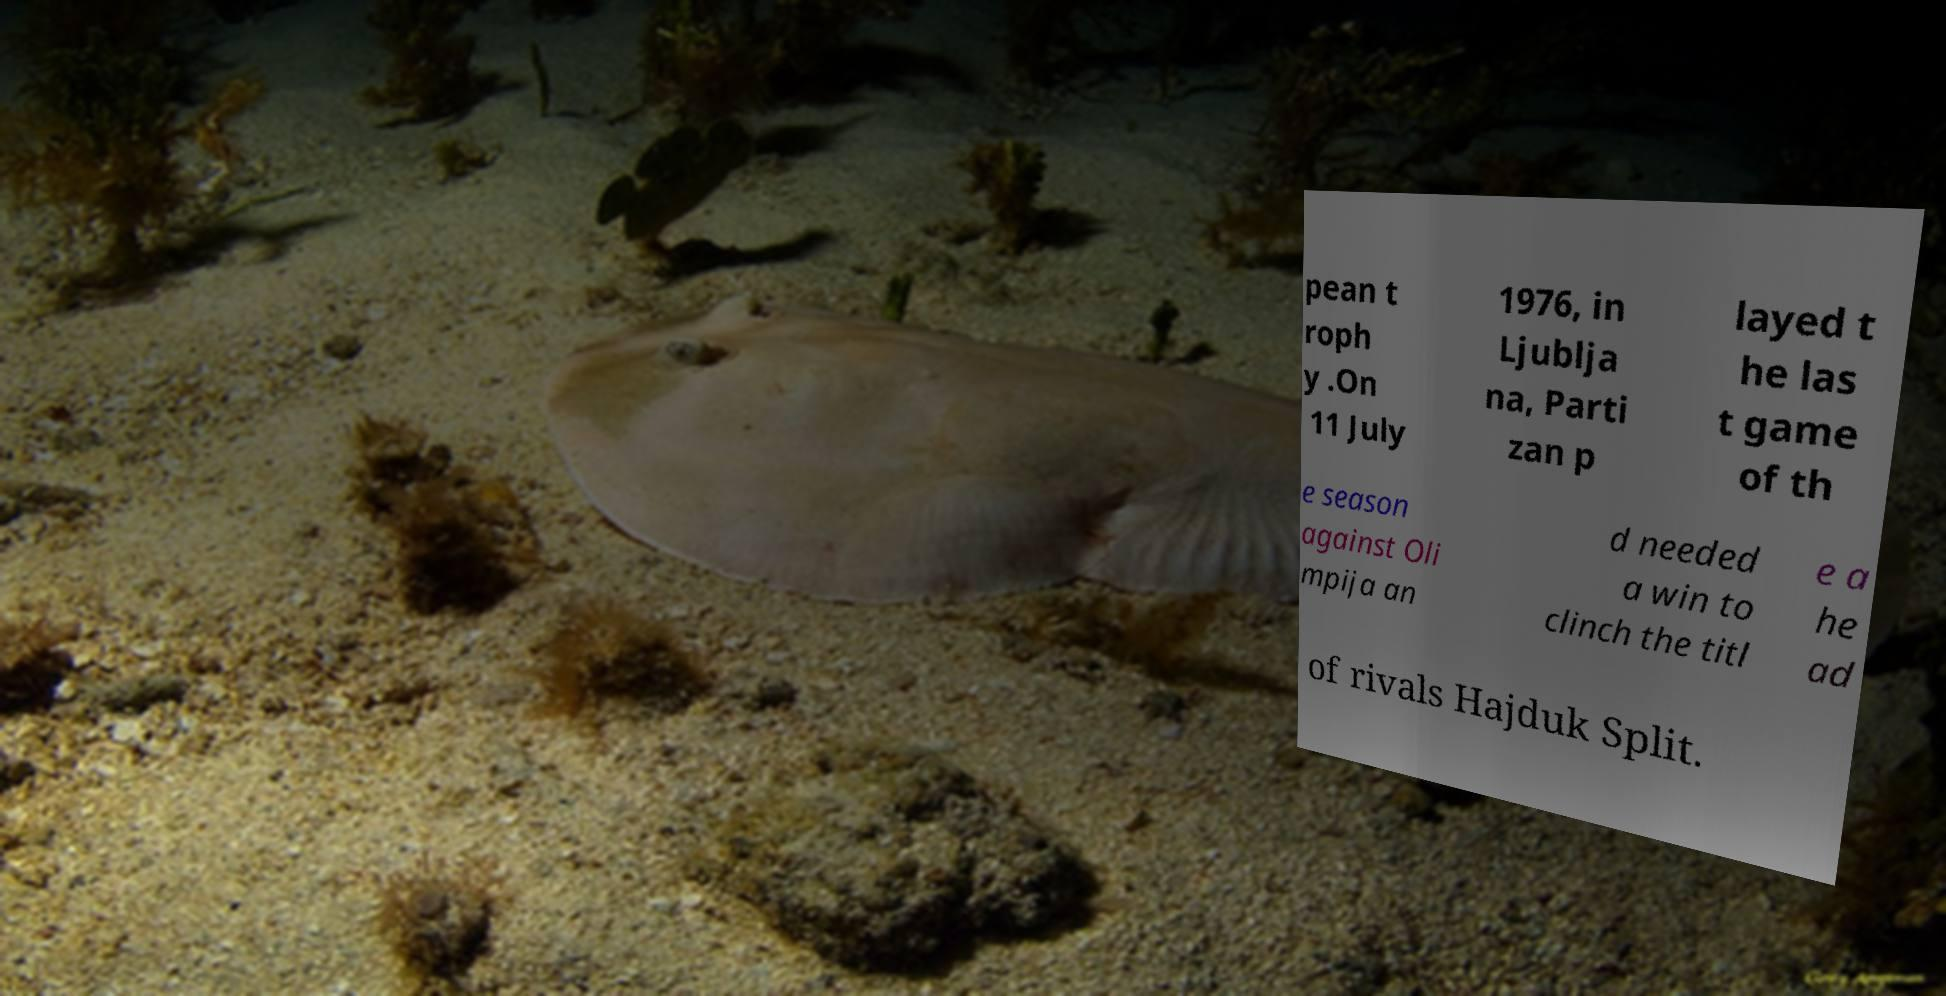Can you read and provide the text displayed in the image?This photo seems to have some interesting text. Can you extract and type it out for me? pean t roph y .On 11 July 1976, in Ljublja na, Parti zan p layed t he las t game of th e season against Oli mpija an d needed a win to clinch the titl e a he ad of rivals Hajduk Split. 